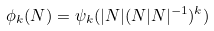<formula> <loc_0><loc_0><loc_500><loc_500>\phi _ { k } ( N ) = \psi _ { k } ( | N | ( N | N | ^ { - 1 } ) ^ { k } )</formula> 